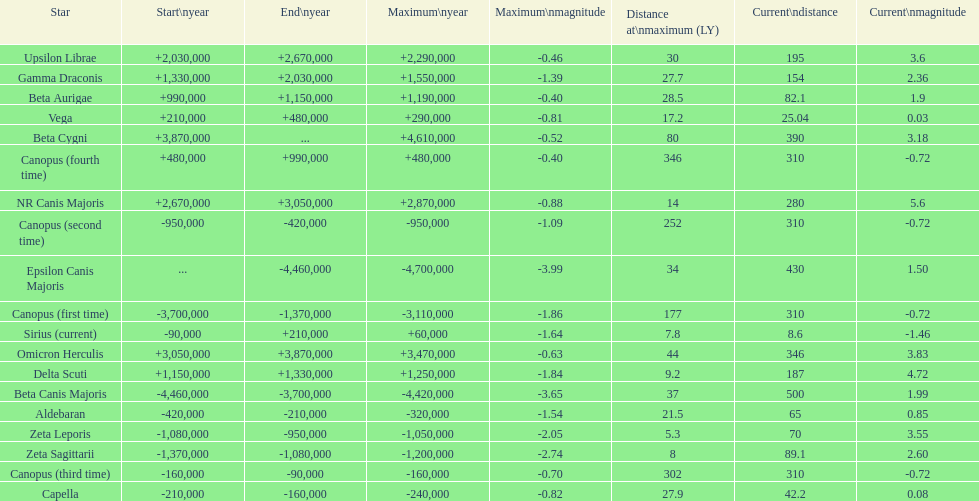What is the difference in the nearest current distance and farthest current distance? 491.4. 